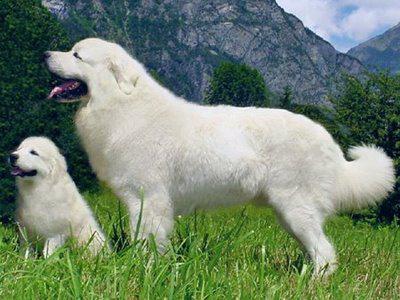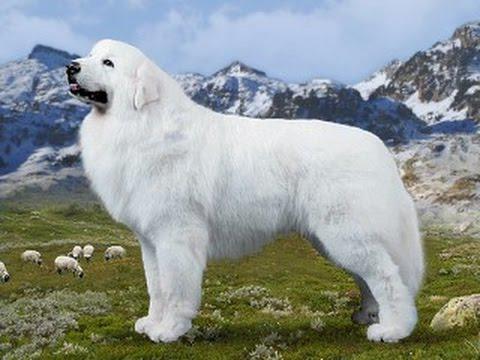The first image is the image on the left, the second image is the image on the right. For the images shown, is this caption "Each image contains a large white dog standing still with its body in profile, and the dogs in the images face the same direction." true? Answer yes or no. Yes. The first image is the image on the left, the second image is the image on the right. For the images shown, is this caption "In at least one image, there is a white dog standing on grass facing left with a back of the sky." true? Answer yes or no. Yes. The first image is the image on the left, the second image is the image on the right. Given the left and right images, does the statement "Exactly two white dogs are on their feet, facing the same direction in an outdoor setting, one of them wearing a collar, both of them open mouthed with tongues showing." hold true? Answer yes or no. No. 